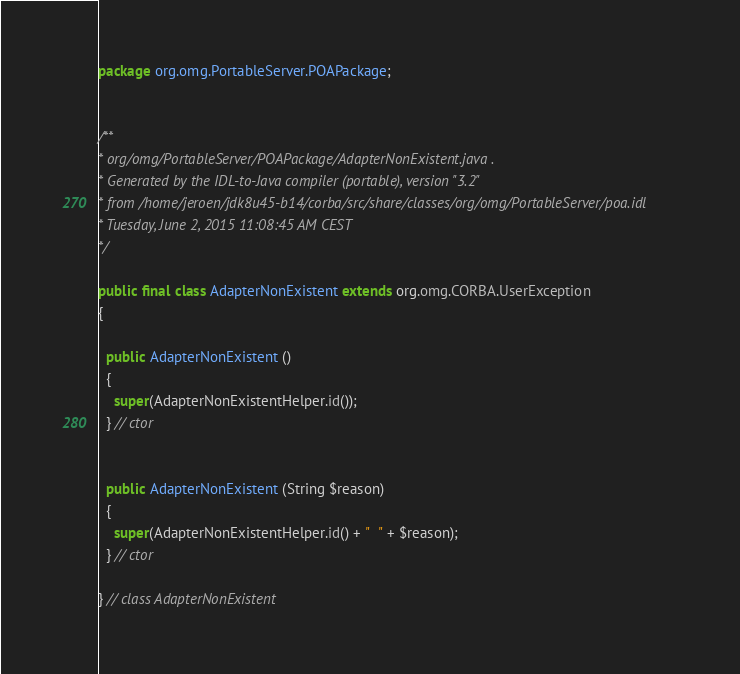<code> <loc_0><loc_0><loc_500><loc_500><_Java_>package org.omg.PortableServer.POAPackage;


/**
* org/omg/PortableServer/POAPackage/AdapterNonExistent.java .
* Generated by the IDL-to-Java compiler (portable), version "3.2"
* from /home/jeroen/jdk8u45-b14/corba/src/share/classes/org/omg/PortableServer/poa.idl
* Tuesday, June 2, 2015 11:08:45 AM CEST
*/

public final class AdapterNonExistent extends org.omg.CORBA.UserException
{

  public AdapterNonExistent ()
  {
    super(AdapterNonExistentHelper.id());
  } // ctor


  public AdapterNonExistent (String $reason)
  {
    super(AdapterNonExistentHelper.id() + "  " + $reason);
  } // ctor

} // class AdapterNonExistent
</code> 